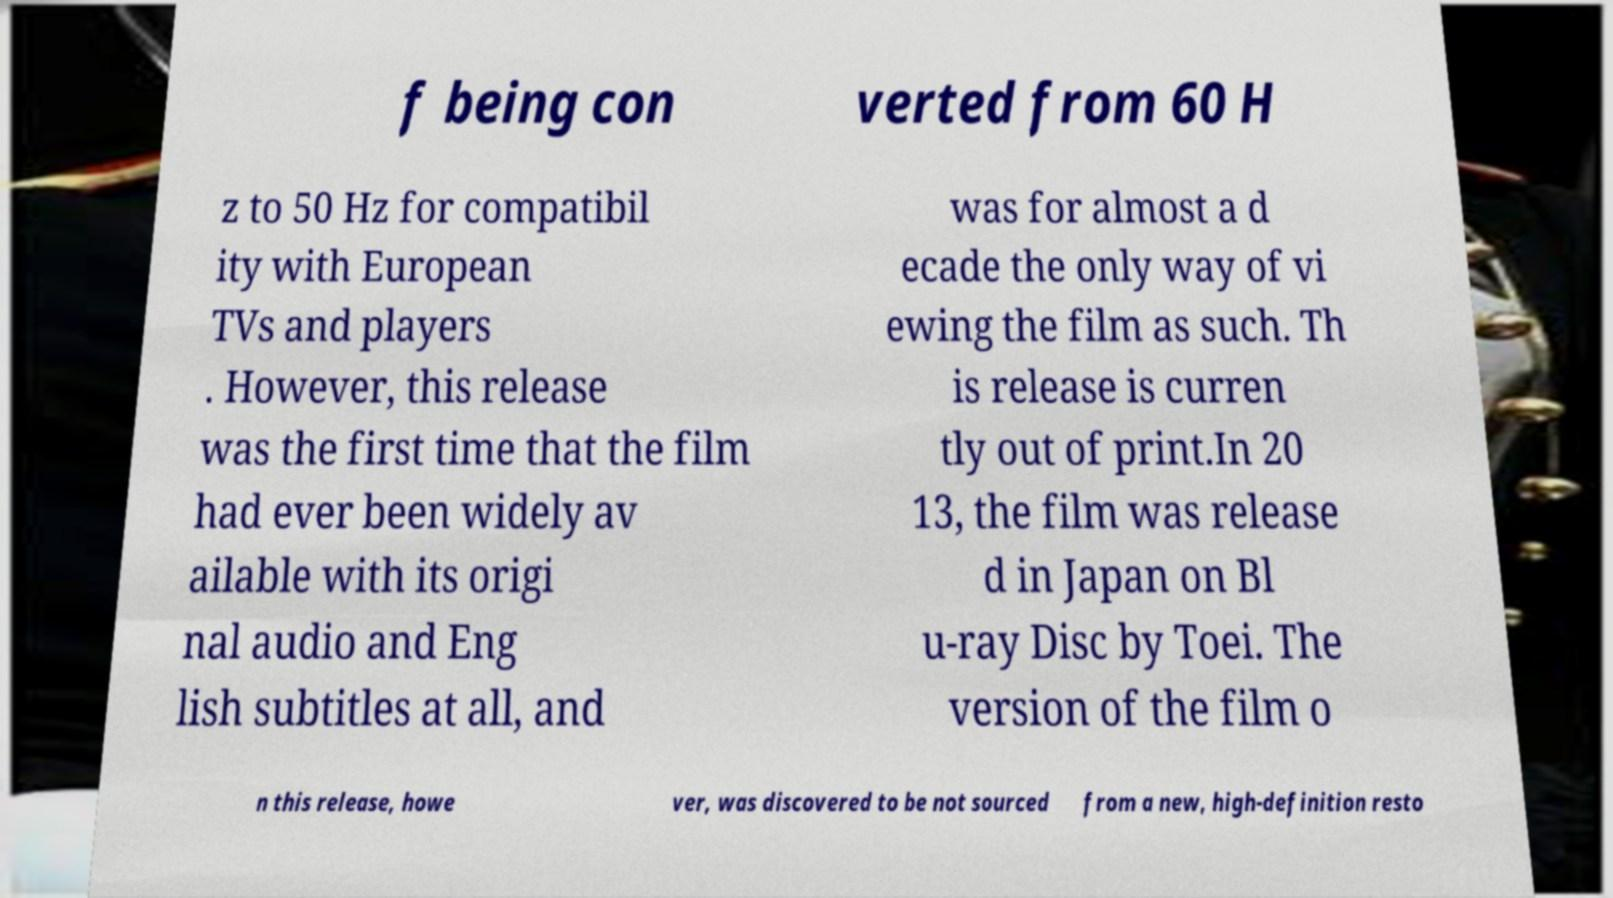Can you accurately transcribe the text from the provided image for me? f being con verted from 60 H z to 50 Hz for compatibil ity with European TVs and players . However, this release was the first time that the film had ever been widely av ailable with its origi nal audio and Eng lish subtitles at all, and was for almost a d ecade the only way of vi ewing the film as such. Th is release is curren tly out of print.In 20 13, the film was release d in Japan on Bl u-ray Disc by Toei. The version of the film o n this release, howe ver, was discovered to be not sourced from a new, high-definition resto 